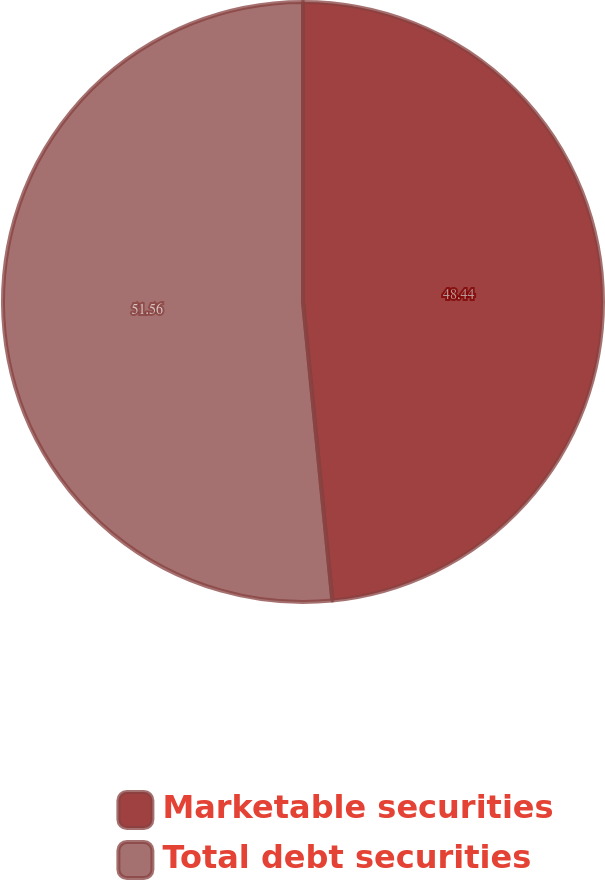<chart> <loc_0><loc_0><loc_500><loc_500><pie_chart><fcel>Marketable securities<fcel>Total debt securities<nl><fcel>48.44%<fcel>51.56%<nl></chart> 